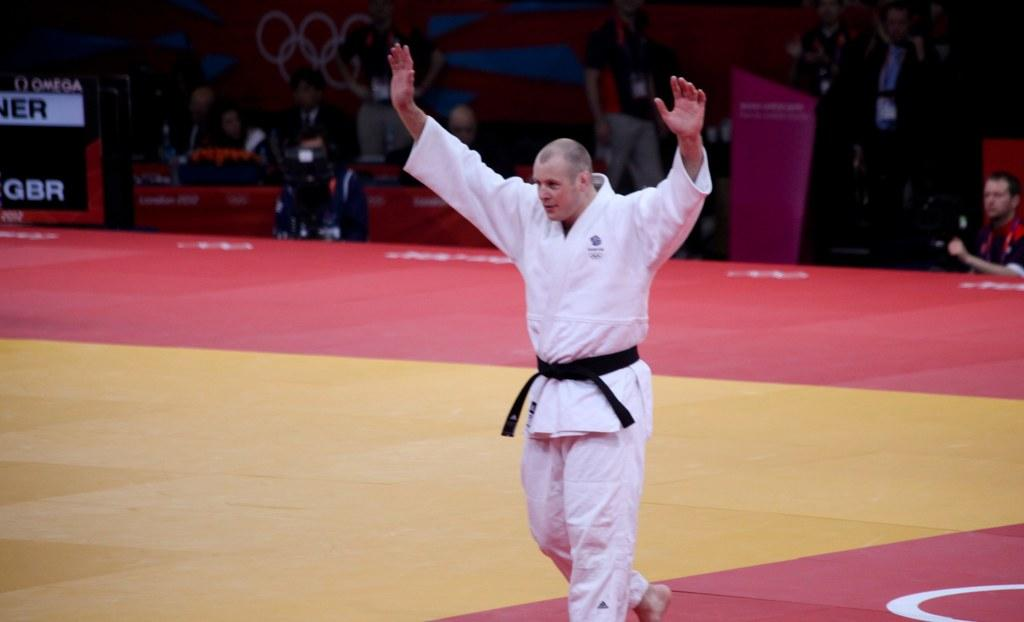What is the main subject of the image? There is a person standing in the center of the image. Where is the person standing? The person is standing on the floor. What can be seen in the background of the image? There are other persons and a cameraman in the background of the image, as well as a wall. What type of beam is being used by the person in the image? There is no beam present in the image; the person is simply standing on the floor. How many pears are visible in the image? There are no pears present in the image. 